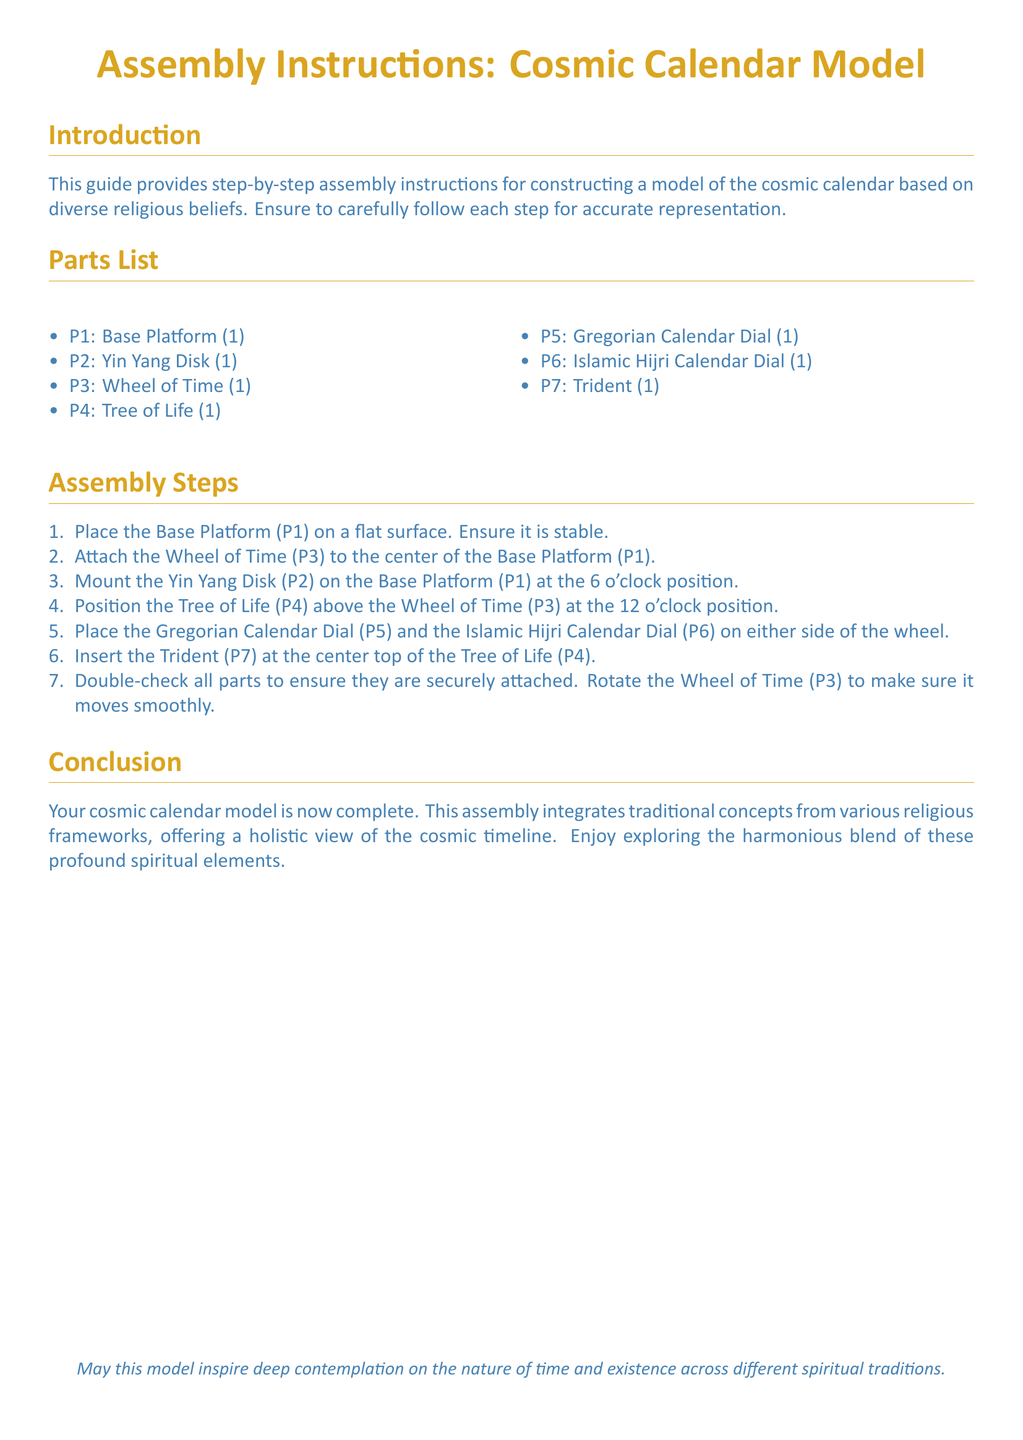What is the title of the document? The title is stated in the center at the beginning of the document.
Answer: Assembly Instructions: Cosmic Calendar Model How many parts are listed in the Parts List? The document explicitly enumerates the items in the Parts List.
Answer: 7 What part is attached at the 12 o'clock position? The position of the Tree of Life is described in the assembly steps.
Answer: Tree of Life What is the color used for the document text? The color of the text is specified in the document format settings.
Answer: Mystical blue Which dial is positioned on the left side of the wheel? The document indicates the arrangement of the dials next to the Wheel of Time.
Answer: Gregorian Calendar Dial What is the first step in the assembly process? The first action in the assembly steps is clearly defined.
Answer: Place the Base Platform What symbol is used to represent balance in the model? The specific part representing balance is mentioned in the Parts List.
Answer: Yin Yang Disk What item is inserted at the center top of the Tree of Life? The assembly steps provide information about the part that goes on top of the Tree of Life.
Answer: Trident 